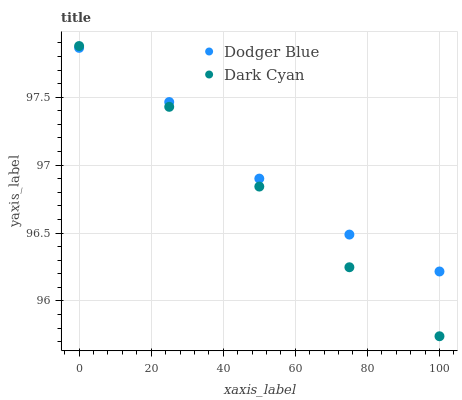Does Dark Cyan have the minimum area under the curve?
Answer yes or no. Yes. Does Dodger Blue have the maximum area under the curve?
Answer yes or no. Yes. Does Dodger Blue have the minimum area under the curve?
Answer yes or no. No. Is Dark Cyan the smoothest?
Answer yes or no. Yes. Is Dodger Blue the roughest?
Answer yes or no. Yes. Is Dodger Blue the smoothest?
Answer yes or no. No. Does Dark Cyan have the lowest value?
Answer yes or no. Yes. Does Dodger Blue have the lowest value?
Answer yes or no. No. Does Dark Cyan have the highest value?
Answer yes or no. Yes. Does Dodger Blue have the highest value?
Answer yes or no. No. Does Dodger Blue intersect Dark Cyan?
Answer yes or no. Yes. Is Dodger Blue less than Dark Cyan?
Answer yes or no. No. Is Dodger Blue greater than Dark Cyan?
Answer yes or no. No. 